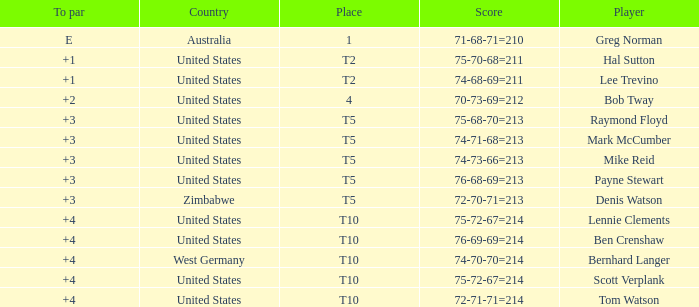What is the location of australia? 1.0. 